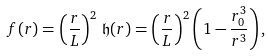<formula> <loc_0><loc_0><loc_500><loc_500>f ( r ) = \left ( \frac { r } { L } \right ) ^ { 2 } \, \mathfrak { h } ( r ) = \left ( \frac { r } { L } \right ) ^ { 2 } \left ( 1 - \frac { r _ { 0 } ^ { 3 } } { r ^ { 3 } } \right ) ,</formula> 